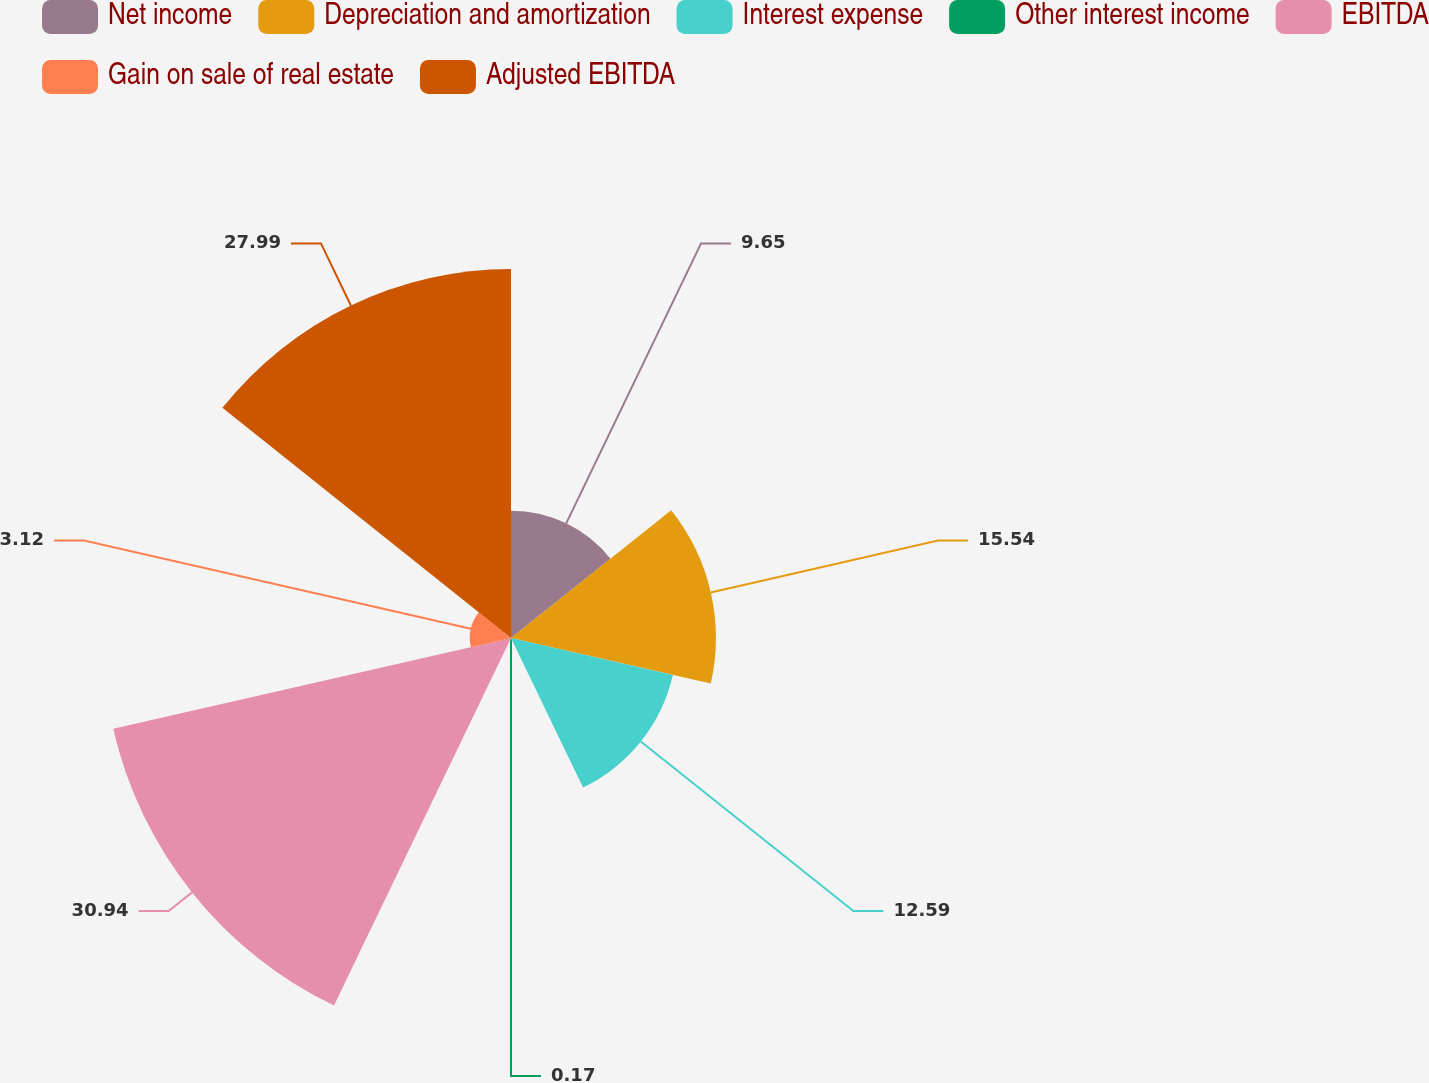Convert chart to OTSL. <chart><loc_0><loc_0><loc_500><loc_500><pie_chart><fcel>Net income<fcel>Depreciation and amortization<fcel>Interest expense<fcel>Other interest income<fcel>EBITDA<fcel>Gain on sale of real estate<fcel>Adjusted EBITDA<nl><fcel>9.65%<fcel>15.54%<fcel>12.59%<fcel>0.17%<fcel>30.94%<fcel>3.12%<fcel>27.99%<nl></chart> 